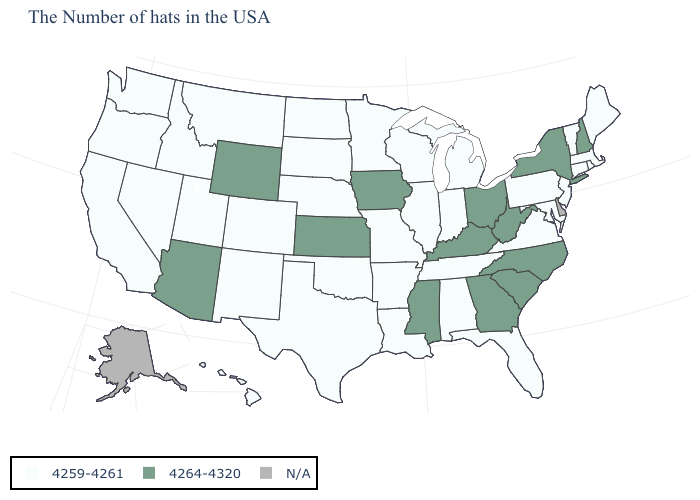Does the first symbol in the legend represent the smallest category?
Concise answer only. Yes. Among the states that border Ohio , which have the lowest value?
Keep it brief. Pennsylvania, Michigan, Indiana. What is the value of South Carolina?
Keep it brief. 4264-4320. What is the value of Hawaii?
Give a very brief answer. 4259-4261. What is the value of Minnesota?
Short answer required. 4259-4261. Name the states that have a value in the range N/A?
Be succinct. Delaware, Alaska. Name the states that have a value in the range 4259-4261?
Keep it brief. Maine, Massachusetts, Rhode Island, Vermont, Connecticut, New Jersey, Maryland, Pennsylvania, Virginia, Florida, Michigan, Indiana, Alabama, Tennessee, Wisconsin, Illinois, Louisiana, Missouri, Arkansas, Minnesota, Nebraska, Oklahoma, Texas, South Dakota, North Dakota, Colorado, New Mexico, Utah, Montana, Idaho, Nevada, California, Washington, Oregon, Hawaii. Name the states that have a value in the range 4264-4320?
Be succinct. New Hampshire, New York, North Carolina, South Carolina, West Virginia, Ohio, Georgia, Kentucky, Mississippi, Iowa, Kansas, Wyoming, Arizona. What is the value of Oklahoma?
Concise answer only. 4259-4261. How many symbols are there in the legend?
Write a very short answer. 3. What is the value of West Virginia?
Answer briefly. 4264-4320. Which states have the lowest value in the USA?
Short answer required. Maine, Massachusetts, Rhode Island, Vermont, Connecticut, New Jersey, Maryland, Pennsylvania, Virginia, Florida, Michigan, Indiana, Alabama, Tennessee, Wisconsin, Illinois, Louisiana, Missouri, Arkansas, Minnesota, Nebraska, Oklahoma, Texas, South Dakota, North Dakota, Colorado, New Mexico, Utah, Montana, Idaho, Nevada, California, Washington, Oregon, Hawaii. What is the value of Illinois?
Write a very short answer. 4259-4261. Which states hav the highest value in the Northeast?
Write a very short answer. New Hampshire, New York. Which states hav the highest value in the West?
Keep it brief. Wyoming, Arizona. 